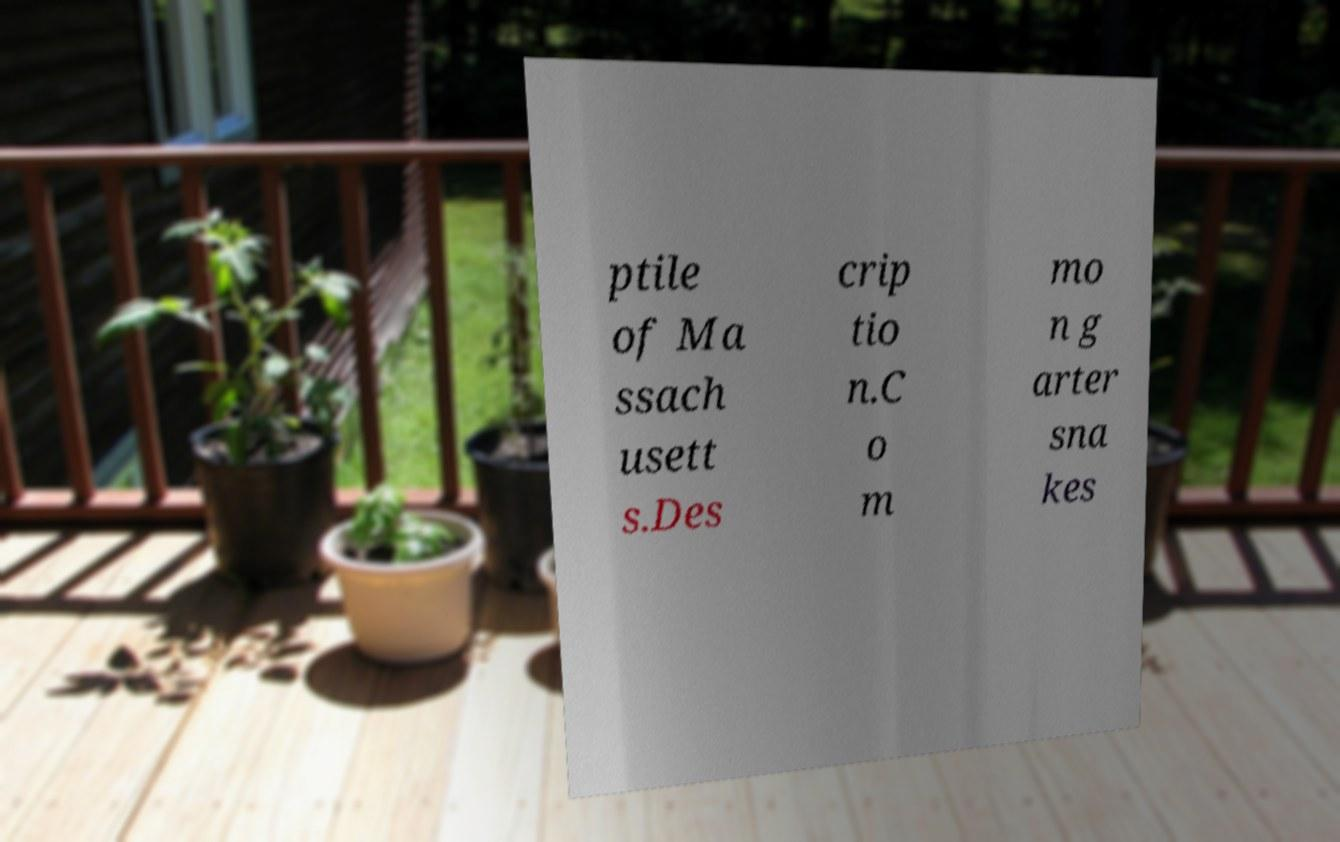I need the written content from this picture converted into text. Can you do that? ptile of Ma ssach usett s.Des crip tio n.C o m mo n g arter sna kes 